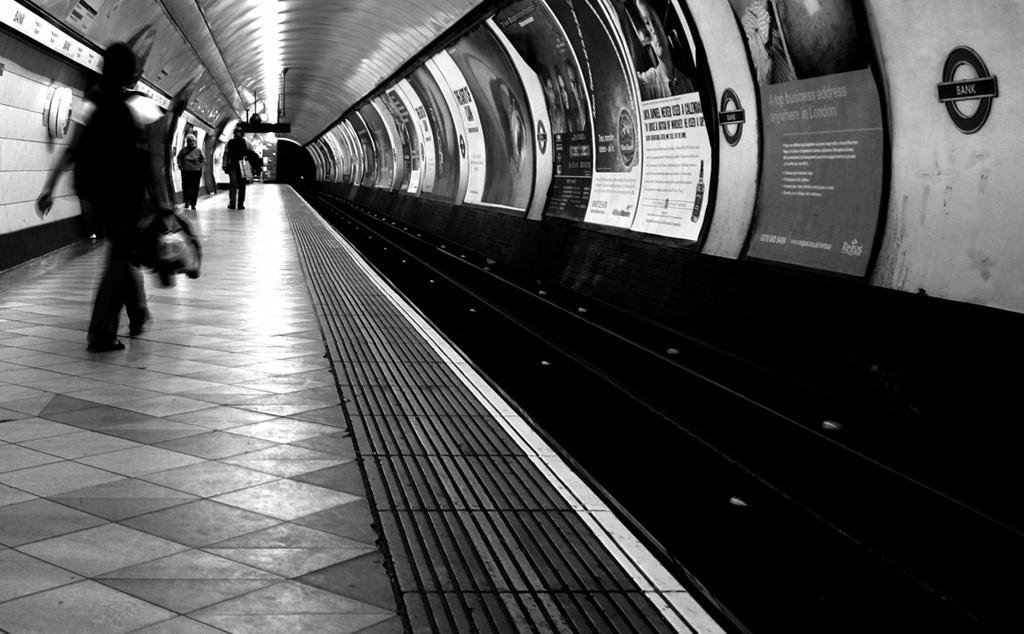What are the people in the image doing? The people in the image are walking. What is the color scheme of the image? The image is in black and white. Where are the posters located in the image? The posters are on the right side of the image. What can be seen on the posters? Unfortunately, the content of the posters cannot be determined from the provided facts. How many spiders are crawling on the coach in the image? There is no coach or spiders present in the image. What type of rock is visible in the image? There is no rock present in the image. 